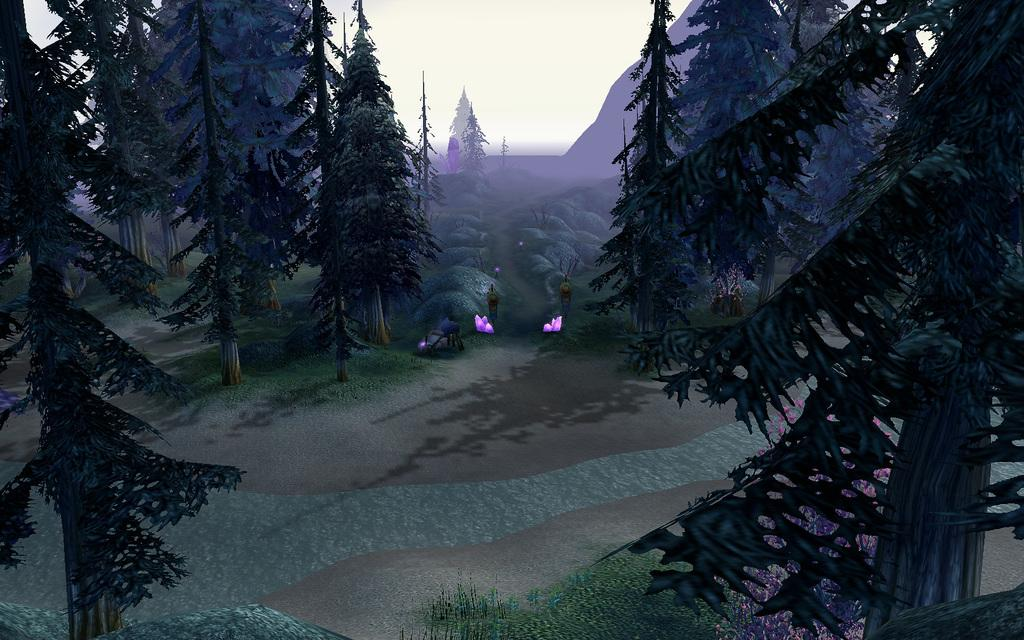What type of vegetation can be seen in the image? There is a group of trees and plants in the image. What geographical feature is present in the image? There is a mountain in the image. What part of the natural environment is visible in the image? The sky is visible in the image. How many bridges can be seen crossing the river in the image? There is no river or bridge present in the image; it features a group of trees, plants, a mountain, and the sky. What type of credit or account is associated with the plants in the image? There is no credit or account associated with the plants in the image; they are simply depicted in the natural environment. 